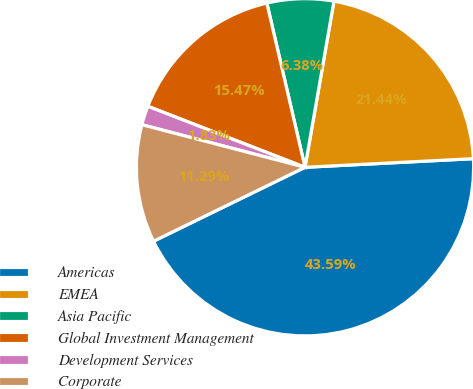<chart> <loc_0><loc_0><loc_500><loc_500><pie_chart><fcel>Americas<fcel>EMEA<fcel>Asia Pacific<fcel>Global Investment Management<fcel>Development Services<fcel>Corporate<nl><fcel>43.59%<fcel>21.44%<fcel>6.38%<fcel>15.47%<fcel>1.83%<fcel>11.29%<nl></chart> 